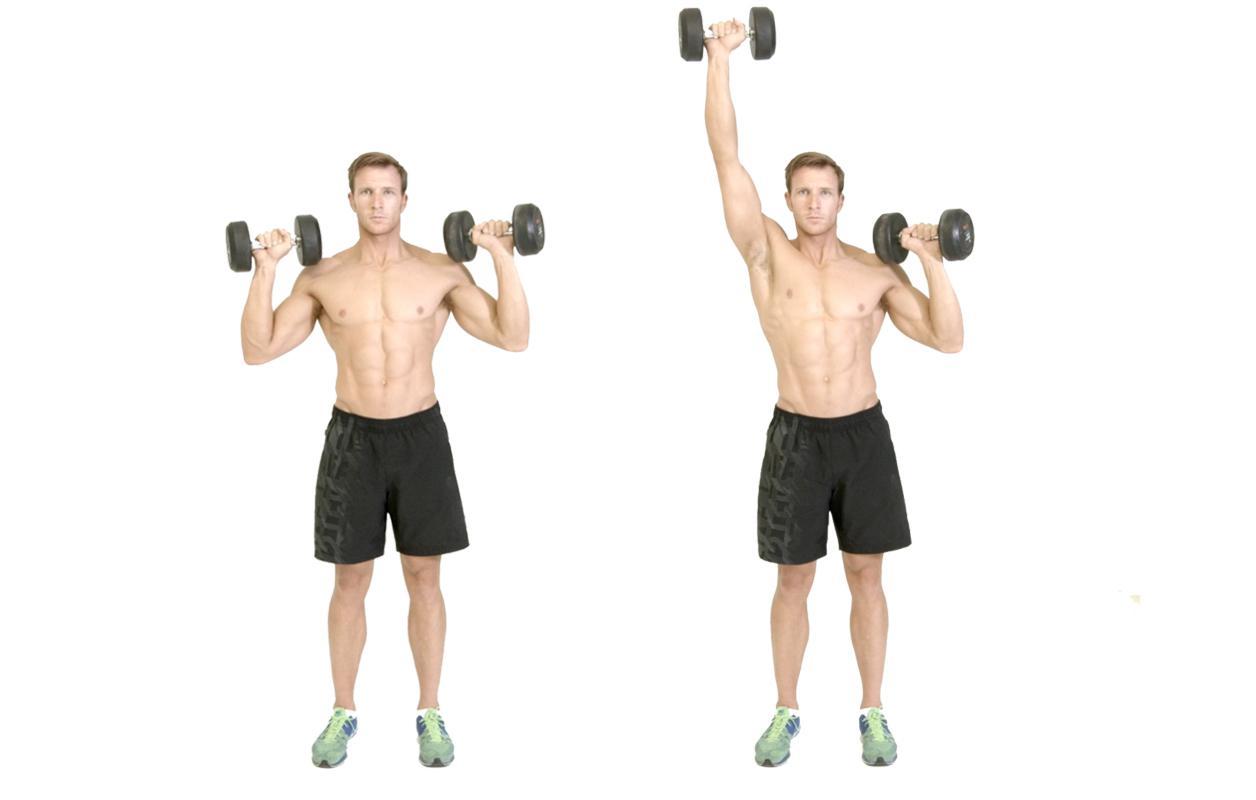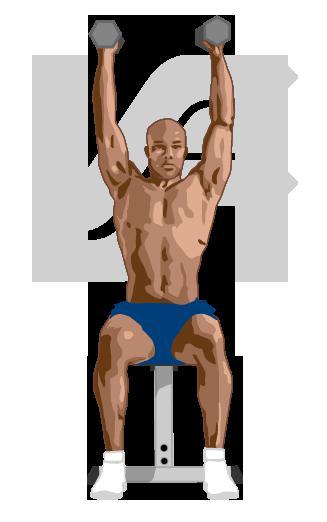The first image is the image on the left, the second image is the image on the right. For the images shown, is this caption "One image shows a woman doing weightlifting exercises" true? Answer yes or no. No. 